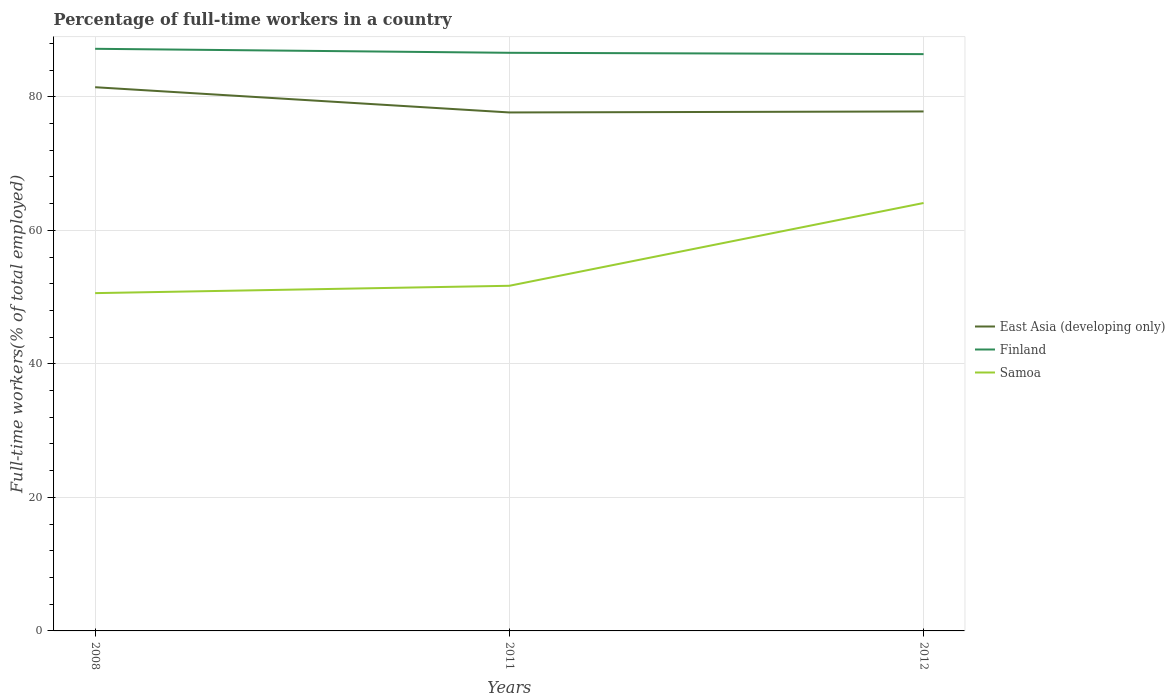How many different coloured lines are there?
Your response must be concise. 3. Across all years, what is the maximum percentage of full-time workers in East Asia (developing only)?
Make the answer very short. 77.66. What is the total percentage of full-time workers in Samoa in the graph?
Keep it short and to the point. -13.5. What is the difference between the highest and the second highest percentage of full-time workers in East Asia (developing only)?
Make the answer very short. 3.78. Is the percentage of full-time workers in Samoa strictly greater than the percentage of full-time workers in East Asia (developing only) over the years?
Provide a succinct answer. Yes. How many lines are there?
Your answer should be very brief. 3. How many years are there in the graph?
Ensure brevity in your answer.  3. What is the difference between two consecutive major ticks on the Y-axis?
Offer a terse response. 20. Does the graph contain any zero values?
Offer a terse response. No. Does the graph contain grids?
Offer a terse response. Yes. How many legend labels are there?
Give a very brief answer. 3. What is the title of the graph?
Give a very brief answer. Percentage of full-time workers in a country. Does "Hong Kong" appear as one of the legend labels in the graph?
Offer a terse response. No. What is the label or title of the Y-axis?
Your response must be concise. Full-time workers(% of total employed). What is the Full-time workers(% of total employed) of East Asia (developing only) in 2008?
Ensure brevity in your answer.  81.44. What is the Full-time workers(% of total employed) of Finland in 2008?
Make the answer very short. 87.2. What is the Full-time workers(% of total employed) of Samoa in 2008?
Ensure brevity in your answer.  50.6. What is the Full-time workers(% of total employed) in East Asia (developing only) in 2011?
Your response must be concise. 77.66. What is the Full-time workers(% of total employed) in Finland in 2011?
Provide a succinct answer. 86.6. What is the Full-time workers(% of total employed) in Samoa in 2011?
Provide a short and direct response. 51.7. What is the Full-time workers(% of total employed) in East Asia (developing only) in 2012?
Give a very brief answer. 77.81. What is the Full-time workers(% of total employed) of Finland in 2012?
Offer a terse response. 86.4. What is the Full-time workers(% of total employed) in Samoa in 2012?
Your answer should be compact. 64.1. Across all years, what is the maximum Full-time workers(% of total employed) in East Asia (developing only)?
Provide a short and direct response. 81.44. Across all years, what is the maximum Full-time workers(% of total employed) in Finland?
Keep it short and to the point. 87.2. Across all years, what is the maximum Full-time workers(% of total employed) in Samoa?
Offer a terse response. 64.1. Across all years, what is the minimum Full-time workers(% of total employed) in East Asia (developing only)?
Offer a terse response. 77.66. Across all years, what is the minimum Full-time workers(% of total employed) of Finland?
Your answer should be compact. 86.4. Across all years, what is the minimum Full-time workers(% of total employed) of Samoa?
Your answer should be very brief. 50.6. What is the total Full-time workers(% of total employed) of East Asia (developing only) in the graph?
Keep it short and to the point. 236.92. What is the total Full-time workers(% of total employed) in Finland in the graph?
Provide a succinct answer. 260.2. What is the total Full-time workers(% of total employed) in Samoa in the graph?
Offer a very short reply. 166.4. What is the difference between the Full-time workers(% of total employed) in East Asia (developing only) in 2008 and that in 2011?
Your answer should be very brief. 3.78. What is the difference between the Full-time workers(% of total employed) of Samoa in 2008 and that in 2011?
Make the answer very short. -1.1. What is the difference between the Full-time workers(% of total employed) in East Asia (developing only) in 2008 and that in 2012?
Offer a very short reply. 3.63. What is the difference between the Full-time workers(% of total employed) of Finland in 2008 and that in 2012?
Give a very brief answer. 0.8. What is the difference between the Full-time workers(% of total employed) of East Asia (developing only) in 2011 and that in 2012?
Your answer should be very brief. -0.15. What is the difference between the Full-time workers(% of total employed) of Finland in 2011 and that in 2012?
Offer a terse response. 0.2. What is the difference between the Full-time workers(% of total employed) of East Asia (developing only) in 2008 and the Full-time workers(% of total employed) of Finland in 2011?
Provide a short and direct response. -5.16. What is the difference between the Full-time workers(% of total employed) in East Asia (developing only) in 2008 and the Full-time workers(% of total employed) in Samoa in 2011?
Your answer should be very brief. 29.74. What is the difference between the Full-time workers(% of total employed) in Finland in 2008 and the Full-time workers(% of total employed) in Samoa in 2011?
Provide a succinct answer. 35.5. What is the difference between the Full-time workers(% of total employed) in East Asia (developing only) in 2008 and the Full-time workers(% of total employed) in Finland in 2012?
Ensure brevity in your answer.  -4.96. What is the difference between the Full-time workers(% of total employed) of East Asia (developing only) in 2008 and the Full-time workers(% of total employed) of Samoa in 2012?
Provide a succinct answer. 17.34. What is the difference between the Full-time workers(% of total employed) in Finland in 2008 and the Full-time workers(% of total employed) in Samoa in 2012?
Provide a succinct answer. 23.1. What is the difference between the Full-time workers(% of total employed) in East Asia (developing only) in 2011 and the Full-time workers(% of total employed) in Finland in 2012?
Keep it short and to the point. -8.74. What is the difference between the Full-time workers(% of total employed) of East Asia (developing only) in 2011 and the Full-time workers(% of total employed) of Samoa in 2012?
Offer a terse response. 13.56. What is the average Full-time workers(% of total employed) of East Asia (developing only) per year?
Ensure brevity in your answer.  78.97. What is the average Full-time workers(% of total employed) in Finland per year?
Provide a succinct answer. 86.73. What is the average Full-time workers(% of total employed) in Samoa per year?
Ensure brevity in your answer.  55.47. In the year 2008, what is the difference between the Full-time workers(% of total employed) in East Asia (developing only) and Full-time workers(% of total employed) in Finland?
Your response must be concise. -5.76. In the year 2008, what is the difference between the Full-time workers(% of total employed) of East Asia (developing only) and Full-time workers(% of total employed) of Samoa?
Provide a short and direct response. 30.84. In the year 2008, what is the difference between the Full-time workers(% of total employed) in Finland and Full-time workers(% of total employed) in Samoa?
Provide a succinct answer. 36.6. In the year 2011, what is the difference between the Full-time workers(% of total employed) in East Asia (developing only) and Full-time workers(% of total employed) in Finland?
Your answer should be compact. -8.94. In the year 2011, what is the difference between the Full-time workers(% of total employed) of East Asia (developing only) and Full-time workers(% of total employed) of Samoa?
Your response must be concise. 25.96. In the year 2011, what is the difference between the Full-time workers(% of total employed) of Finland and Full-time workers(% of total employed) of Samoa?
Your answer should be very brief. 34.9. In the year 2012, what is the difference between the Full-time workers(% of total employed) in East Asia (developing only) and Full-time workers(% of total employed) in Finland?
Provide a succinct answer. -8.59. In the year 2012, what is the difference between the Full-time workers(% of total employed) of East Asia (developing only) and Full-time workers(% of total employed) of Samoa?
Your answer should be very brief. 13.71. In the year 2012, what is the difference between the Full-time workers(% of total employed) of Finland and Full-time workers(% of total employed) of Samoa?
Provide a succinct answer. 22.3. What is the ratio of the Full-time workers(% of total employed) in East Asia (developing only) in 2008 to that in 2011?
Provide a succinct answer. 1.05. What is the ratio of the Full-time workers(% of total employed) of Samoa in 2008 to that in 2011?
Your answer should be compact. 0.98. What is the ratio of the Full-time workers(% of total employed) of East Asia (developing only) in 2008 to that in 2012?
Offer a terse response. 1.05. What is the ratio of the Full-time workers(% of total employed) in Finland in 2008 to that in 2012?
Your response must be concise. 1.01. What is the ratio of the Full-time workers(% of total employed) in Samoa in 2008 to that in 2012?
Make the answer very short. 0.79. What is the ratio of the Full-time workers(% of total employed) in Samoa in 2011 to that in 2012?
Offer a terse response. 0.81. What is the difference between the highest and the second highest Full-time workers(% of total employed) in East Asia (developing only)?
Keep it short and to the point. 3.63. What is the difference between the highest and the second highest Full-time workers(% of total employed) of Finland?
Make the answer very short. 0.6. What is the difference between the highest and the second highest Full-time workers(% of total employed) in Samoa?
Your answer should be very brief. 12.4. What is the difference between the highest and the lowest Full-time workers(% of total employed) of East Asia (developing only)?
Ensure brevity in your answer.  3.78. 